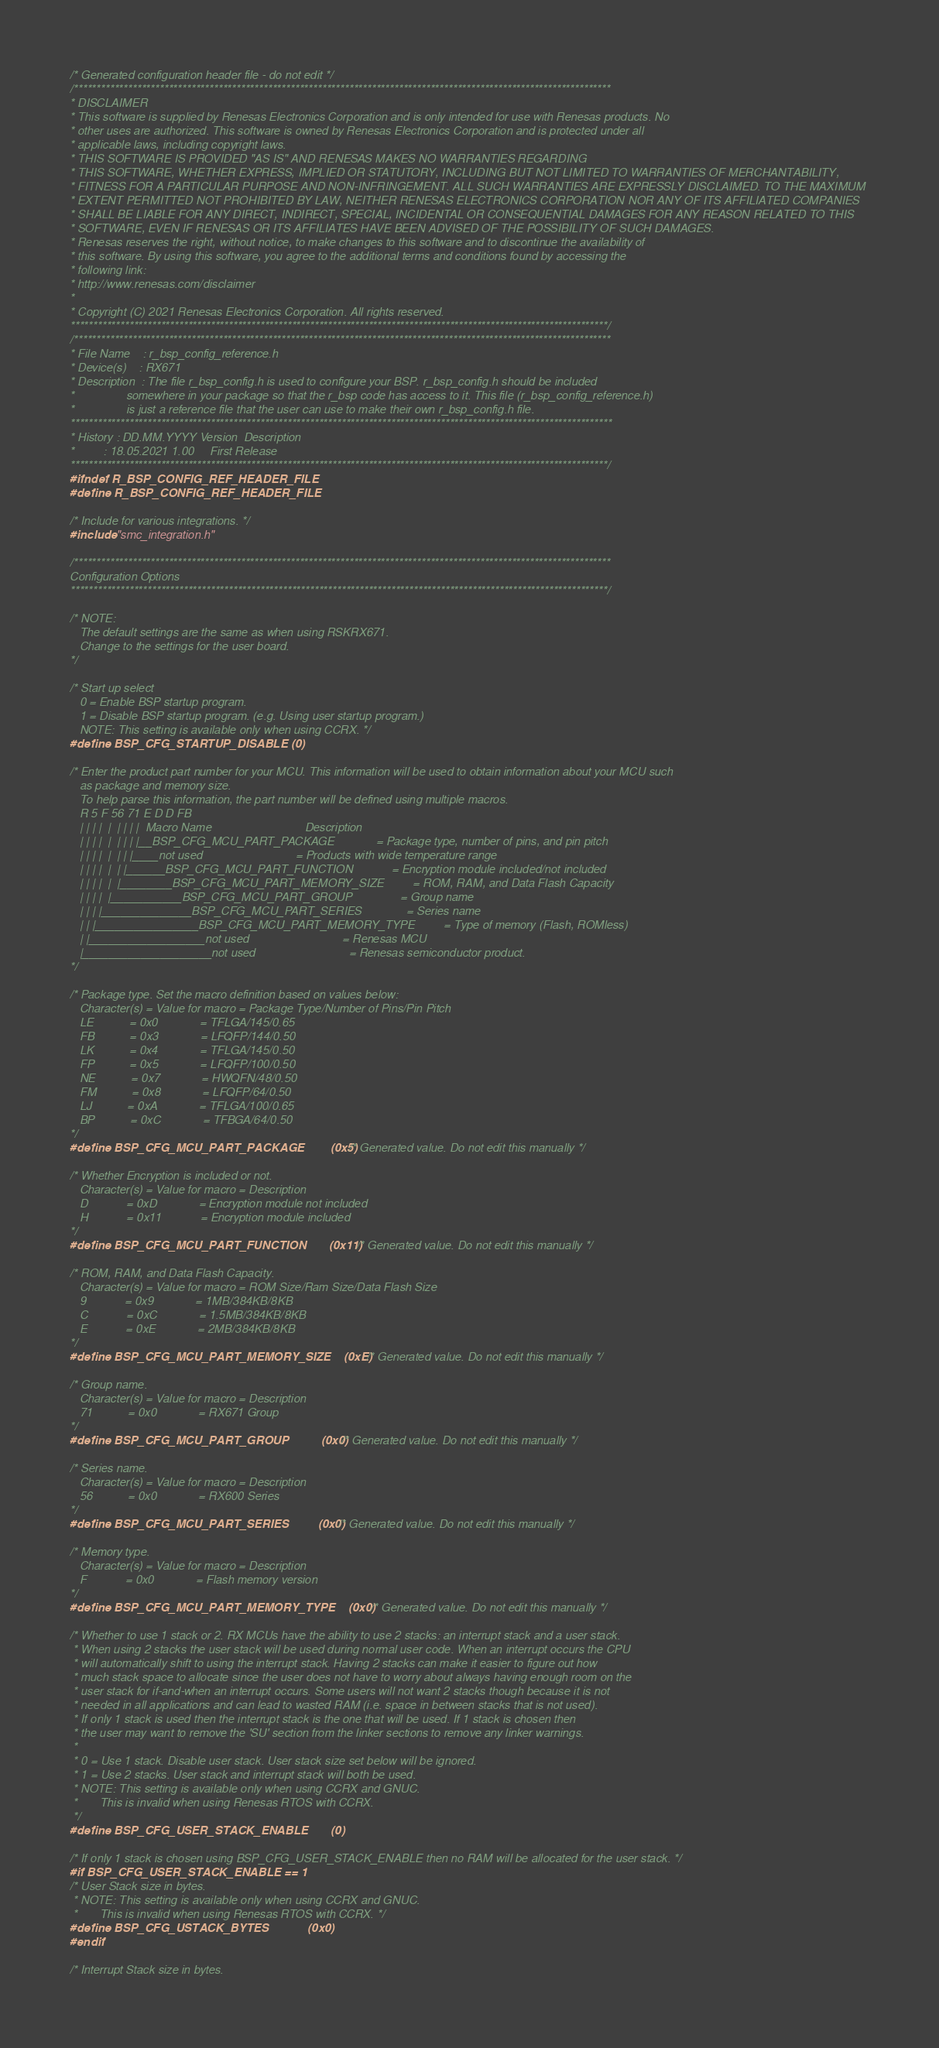<code> <loc_0><loc_0><loc_500><loc_500><_C_>/* Generated configuration header file - do not edit */
/***********************************************************************************************************************
* DISCLAIMER
* This software is supplied by Renesas Electronics Corporation and is only intended for use with Renesas products. No 
* other uses are authorized. This software is owned by Renesas Electronics Corporation and is protected under all 
* applicable laws, including copyright laws. 
* THIS SOFTWARE IS PROVIDED "AS IS" AND RENESAS MAKES NO WARRANTIES REGARDING
* THIS SOFTWARE, WHETHER EXPRESS, IMPLIED OR STATUTORY, INCLUDING BUT NOT LIMITED TO WARRANTIES OF MERCHANTABILITY, 
* FITNESS FOR A PARTICULAR PURPOSE AND NON-INFRINGEMENT. ALL SUCH WARRANTIES ARE EXPRESSLY DISCLAIMED. TO THE MAXIMUM 
* EXTENT PERMITTED NOT PROHIBITED BY LAW, NEITHER RENESAS ELECTRONICS CORPORATION NOR ANY OF ITS AFFILIATED COMPANIES 
* SHALL BE LIABLE FOR ANY DIRECT, INDIRECT, SPECIAL, INCIDENTAL OR CONSEQUENTIAL DAMAGES FOR ANY REASON RELATED TO THIS 
* SOFTWARE, EVEN IF RENESAS OR ITS AFFILIATES HAVE BEEN ADVISED OF THE POSSIBILITY OF SUCH DAMAGES.
* Renesas reserves the right, without notice, to make changes to this software and to discontinue the availability of 
* this software. By using this software, you agree to the additional terms and conditions found by accessing the 
* following link:
* http://www.renesas.com/disclaimer
*
* Copyright (C) 2021 Renesas Electronics Corporation. All rights reserved.
***********************************************************************************************************************/
/***********************************************************************************************************************
* File Name    : r_bsp_config_reference.h
* Device(s)    : RX671
* Description  : The file r_bsp_config.h is used to configure your BSP. r_bsp_config.h should be included
*                somewhere in your package so that the r_bsp code has access to it. This file (r_bsp_config_reference.h)
*                is just a reference file that the user can use to make their own r_bsp_config.h file.
************************************************************************************************************************
* History : DD.MM.YYYY Version  Description
*         : 18.05.2021 1.00     First Release
***********************************************************************************************************************/
#ifndef R_BSP_CONFIG_REF_HEADER_FILE
#define R_BSP_CONFIG_REF_HEADER_FILE

/* Include for various integrations. */
#include "smc_integration.h"

/***********************************************************************************************************************
Configuration Options
***********************************************************************************************************************/

/* NOTE:
   The default settings are the same as when using RSKRX671.
   Change to the settings for the user board.
*/

/* Start up select
   0 = Enable BSP startup program.
   1 = Disable BSP startup program. (e.g. Using user startup program.)
   NOTE: This setting is available only when using CCRX. */
#define BSP_CFG_STARTUP_DISABLE (0)

/* Enter the product part number for your MCU. This information will be used to obtain information about your MCU such 
   as package and memory size.
   To help parse this information, the part number will be defined using multiple macros.
   R 5 F 56 71 E D D FB
   | | | |  |  | | | |  Macro Name                             Description
   | | | |  |  | | | |__BSP_CFG_MCU_PART_PACKAGE             = Package type, number of pins, and pin pitch
   | | | |  |  | | |____not used                             = Products with wide temperature range
   | | | |  |  | |______BSP_CFG_MCU_PART_FUNCTION            = Encryption module included/not included
   | | | |  |  |________BSP_CFG_MCU_PART_MEMORY_SIZE         = ROM, RAM, and Data Flash Capacity
   | | | |  |___________BSP_CFG_MCU_PART_GROUP               = Group name
   | | | |______________BSP_CFG_MCU_PART_SERIES              = Series name
   | | |________________BSP_CFG_MCU_PART_MEMORY_TYPE         = Type of memory (Flash, ROMless)
   | |__________________not used                             = Renesas MCU
   |____________________not used                             = Renesas semiconductor product.
*/

/* Package type. Set the macro definition based on values below:
   Character(s) = Value for macro = Package Type/Number of Pins/Pin Pitch
   LE           = 0x0             = TFLGA/145/0.65
   FB           = 0x3             = LFQFP/144/0.50
   LK           = 0x4             = TFLGA/145/0.50
   FP           = 0x5             = LFQFP/100/0.50
   NE           = 0x7             = HWQFN/48/0.50
   FM           = 0x8             = LFQFP/64/0.50
   LJ           = 0xA             = TFLGA/100/0.65
   BP           = 0xC             = TFBGA/64/0.50
*/
#define BSP_CFG_MCU_PART_PACKAGE        (0x5) /* Generated value. Do not edit this manually */

/* Whether Encryption is included or not.
   Character(s) = Value for macro = Description
   D            = 0xD             = Encryption module not included
   H            = 0x11            = Encryption module included
*/
#define BSP_CFG_MCU_PART_FUNCTION       (0x11) /* Generated value. Do not edit this manually */

/* ROM, RAM, and Data Flash Capacity.
   Character(s) = Value for macro = ROM Size/Ram Size/Data Flash Size
   9            = 0x9             = 1MB/384KB/8KB
   C            = 0xC             = 1.5MB/384KB/8KB
   E            = 0xE             = 2MB/384KB/8KB
*/
#define BSP_CFG_MCU_PART_MEMORY_SIZE    (0xE) /* Generated value. Do not edit this manually */

/* Group name.
   Character(s) = Value for macro = Description
   71           = 0x0             = RX671 Group
*/
#define BSP_CFG_MCU_PART_GROUP          (0x0) /* Generated value. Do not edit this manually */

/* Series name.
   Character(s) = Value for macro = Description
   56           = 0x0             = RX600 Series
*/
#define BSP_CFG_MCU_PART_SERIES         (0x0) /* Generated value. Do not edit this manually */

/* Memory type.
   Character(s) = Value for macro = Description
   F            = 0x0             = Flash memory version
*/
#define BSP_CFG_MCU_PART_MEMORY_TYPE    (0x0) /* Generated value. Do not edit this manually */

/* Whether to use 1 stack or 2. RX MCUs have the ability to use 2 stacks: an interrupt stack and a user stack.
 * When using 2 stacks the user stack will be used during normal user code. When an interrupt occurs the CPU
 * will automatically shift to using the interrupt stack. Having 2 stacks can make it easier to figure out how
 * much stack space to allocate since the user does not have to worry about always having enough room on the
 * user stack for if-and-when an interrupt occurs. Some users will not want 2 stacks though because it is not
 * needed in all applications and can lead to wasted RAM (i.e. space in between stacks that is not used).
 * If only 1 stack is used then the interrupt stack is the one that will be used. If 1 stack is chosen then
 * the user may want to remove the 'SU' section from the linker sections to remove any linker warnings.
 *
 * 0 = Use 1 stack. Disable user stack. User stack size set below will be ignored.
 * 1 = Use 2 stacks. User stack and interrupt stack will both be used.
 * NOTE: This setting is available only when using CCRX and GNUC.
 *       This is invalid when using Renesas RTOS with CCRX.
 */
#define BSP_CFG_USER_STACK_ENABLE       (0)

/* If only 1 stack is chosen using BSP_CFG_USER_STACK_ENABLE then no RAM will be allocated for the user stack. */
#if BSP_CFG_USER_STACK_ENABLE == 1
/* User Stack size in bytes.
 * NOTE: This setting is available only when using CCRX and GNUC.
 *       This is invalid when using Renesas RTOS with CCRX. */
#define BSP_CFG_USTACK_BYTES            (0x0)
#endif

/* Interrupt Stack size in bytes.</code> 